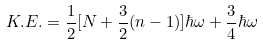<formula> <loc_0><loc_0><loc_500><loc_500>K . E . = \frac { 1 } { 2 } [ N + \frac { 3 } { 2 } ( n - 1 ) ] \hbar { \omega } + \frac { 3 } { 4 } \hbar { \omega }</formula> 